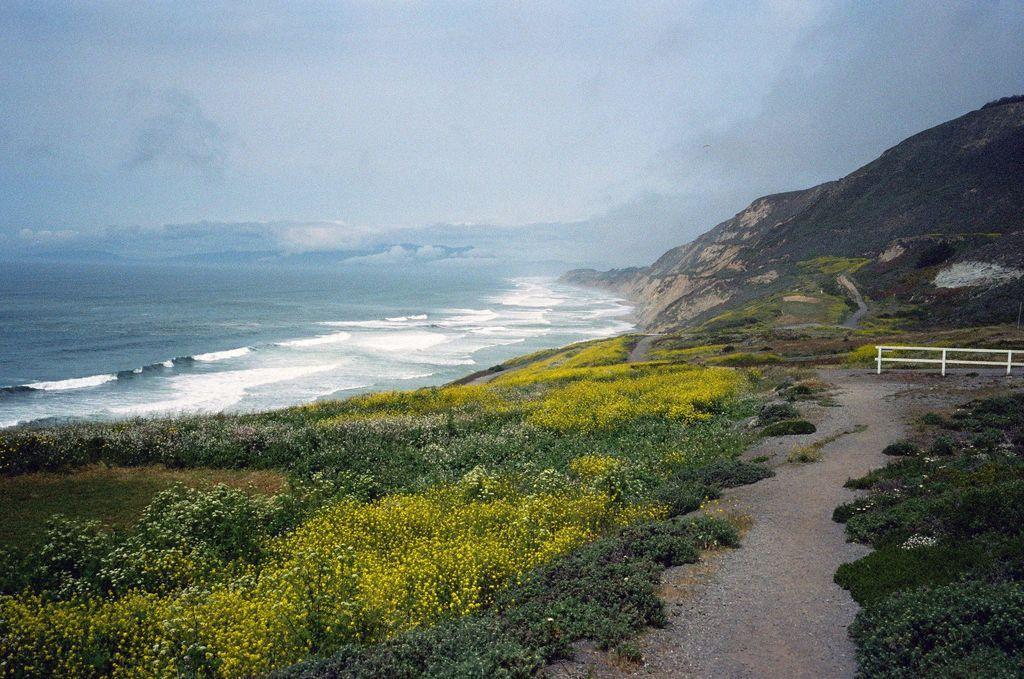Please provide a concise description of this image. On the bottom of the image we can see yellow color flowers on the plant. On the right we can see white color fencing. On the left we can see ocean. On the background we can see mountain. On the top we can see sky and clouds. 